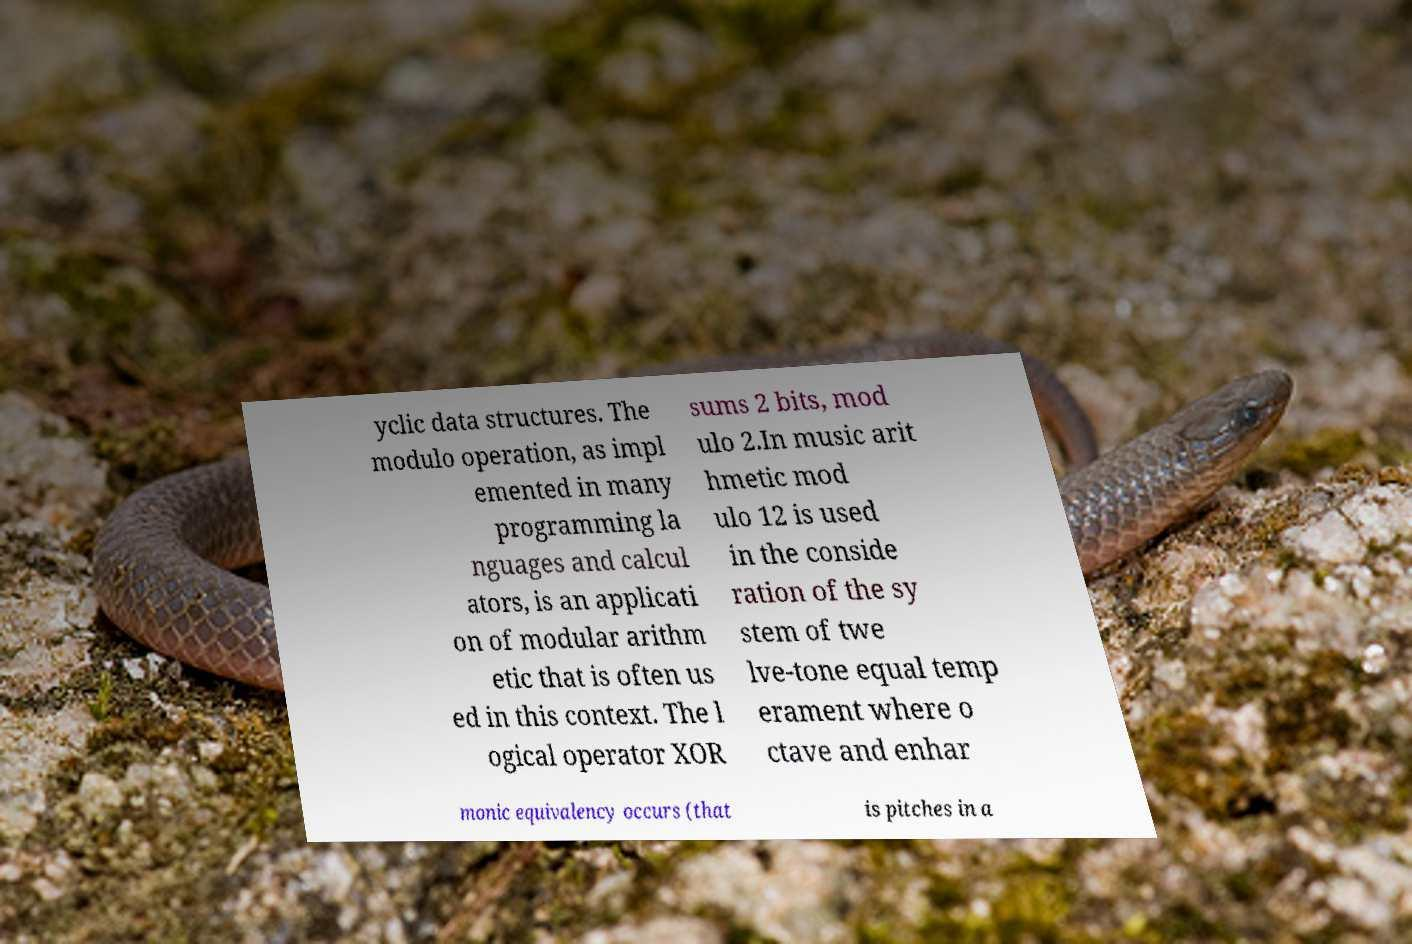Please identify and transcribe the text found in this image. yclic data structures. The modulo operation, as impl emented in many programming la nguages and calcul ators, is an applicati on of modular arithm etic that is often us ed in this context. The l ogical operator XOR sums 2 bits, mod ulo 2.In music arit hmetic mod ulo 12 is used in the conside ration of the sy stem of twe lve-tone equal temp erament where o ctave and enhar monic equivalency occurs (that is pitches in a 